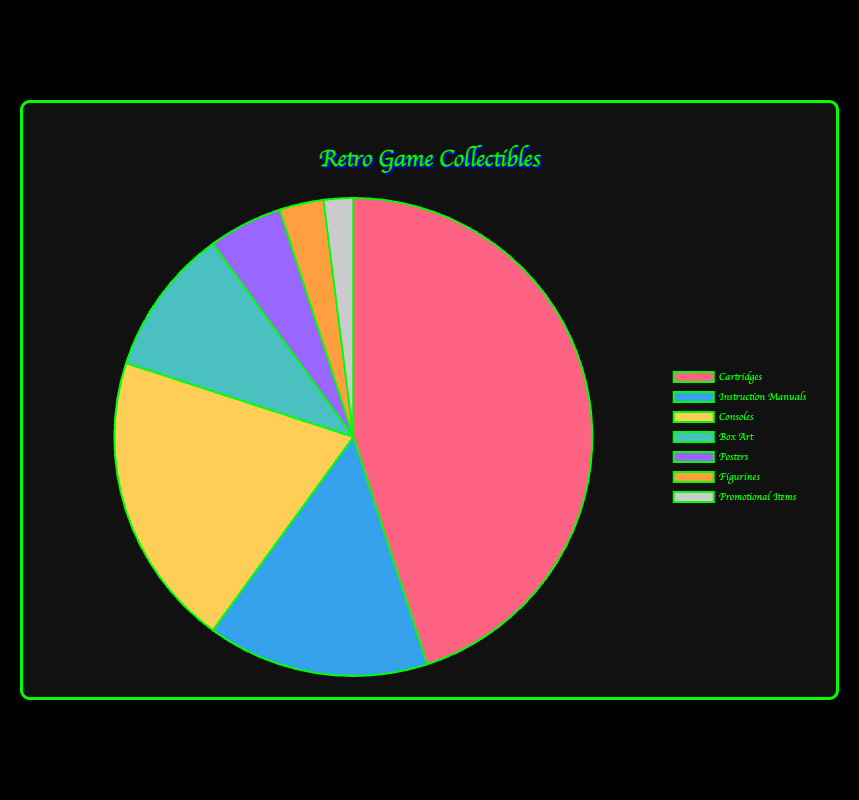What's the most owned type of retro game collectible? The pie chart shows percentages for each type of collectible. The type with the largest percentage is the most owned. By looking at the chart, Cartridges have the largest portion at 45%.
Answer: Cartridges Which type of collectible is owned the least by enthusiasts? To determine the least owned collectible, identify the category with the smallest percentage in the pie chart. Promotional Items have the smallest portion at 2%.
Answer: Promotional Items What is the combined percentage of Cartridges and Consoles owned by enthusiasts? Add the percentages for Cartridges and Consoles. Cartridges have 45% and Consoles have 20%, so the total is 45% + 20% = 65%.
Answer: 65% How much more popular are Cartridges compared to Instruction Manuals based on percentage? Subtract the percentage of Instruction Manuals from the percentage of Cartridges to find how much more popular Cartridges are. Cartridges are at 45% and Instruction Manuals are at 15%, so 45% - 15% = 30%.
Answer: 30% Which type of collectible represents exactly twice the ownership percentage of Posters? Identify the percentage of Posters and find the category that is double that percentage. Posters have 5%, so double is 10%. Box Art has a percentage of 10%.
Answer: Box Art What is the total percentage of collectibles that are not physical game elements (excluding Cartridges, Consoles, and Box Art)? Add the percentages of Instruction Manuals, Posters, Figurines, and Promotional Items. 15% (Instruction Manuals) + 5% (Posters) + 3% (Figurines) + 2% (Promotional Items) = 25%.
Answer: 25% Comparing Box Art and Posters, which has a higher percentage and by how much? Subtract the percentage of Posters from the percentage of Box Art. Box Art has 10% and Posters have 5%, so 10% - 5% = 5%.
Answer: Box Art by 5% Which type of collectible, out of Cartridges and Consoles, has a higher percentage, and what is the absolute difference between their percentages? Compare the percentages of Cartridges and Consoles. Cartridges have 45% and Consoles have 20%. Subtract the smaller from the larger, 45% - 20% = 25%.
Answer: Cartridges by 25% What percentage of the total does Box Art and Figurines together represent? Add the percentages of Box Art and Figurines. Box Art is at 10% and Figurines are at 3%, so 10% + 3% = 13%.
Answer: 13% Considering only Posters, Figurines, and Promotional Items, what is their combined percentage? Add the percentages of Posters, Figurines, and Promotional Items. Posters have 5%, Figurines have 3%, and Promotional Items have 2%, so 5% + 3% + 2% = 10%.
Answer: 10% 